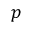Convert formula to latex. <formula><loc_0><loc_0><loc_500><loc_500>p</formula> 